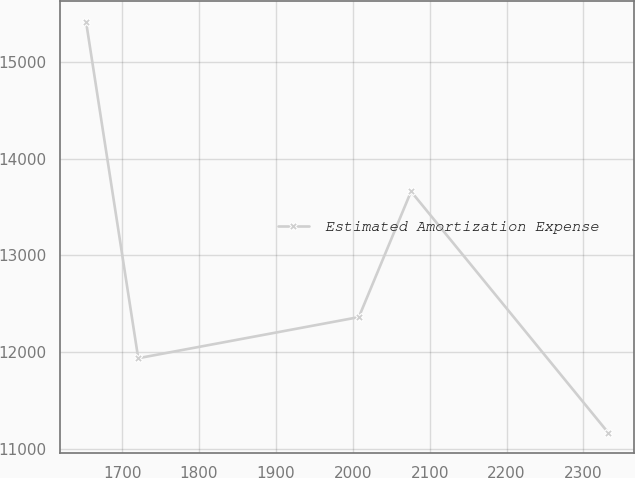<chart> <loc_0><loc_0><loc_500><loc_500><line_chart><ecel><fcel>Estimated Amortization Expense<nl><fcel>1652.99<fcel>15419.6<nl><fcel>1720.9<fcel>11936.5<nl><fcel>2007.88<fcel>12361.7<nl><fcel>2075.79<fcel>13661.7<nl><fcel>2332.1<fcel>11167.1<nl></chart> 